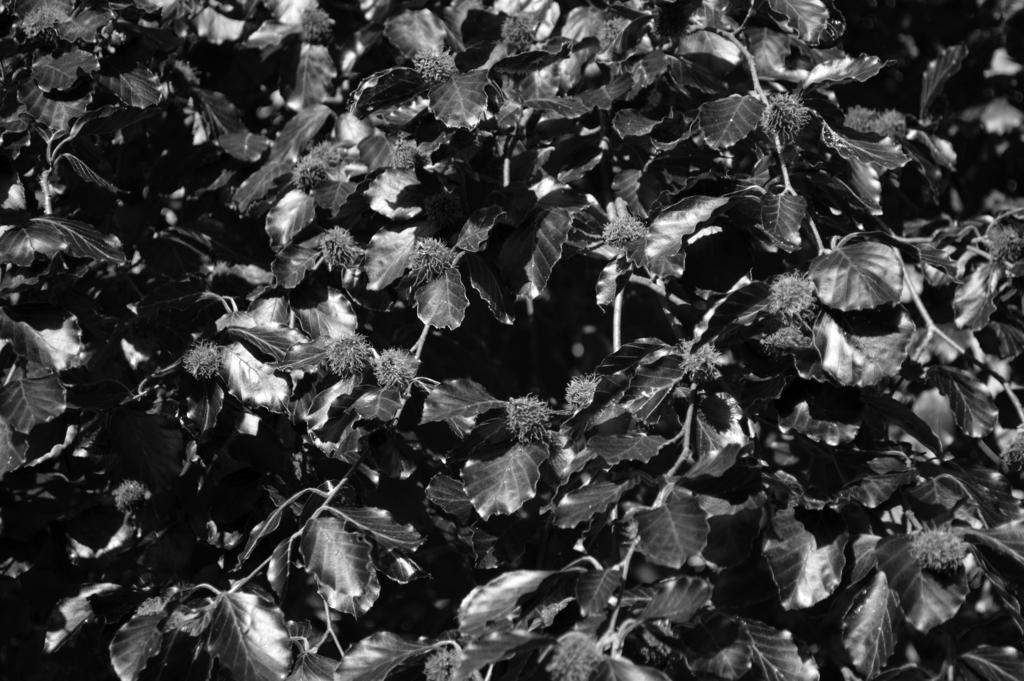In one or two sentences, can you explain what this image depicts? This is a black and white image. We can see there are leaves to the stems. 